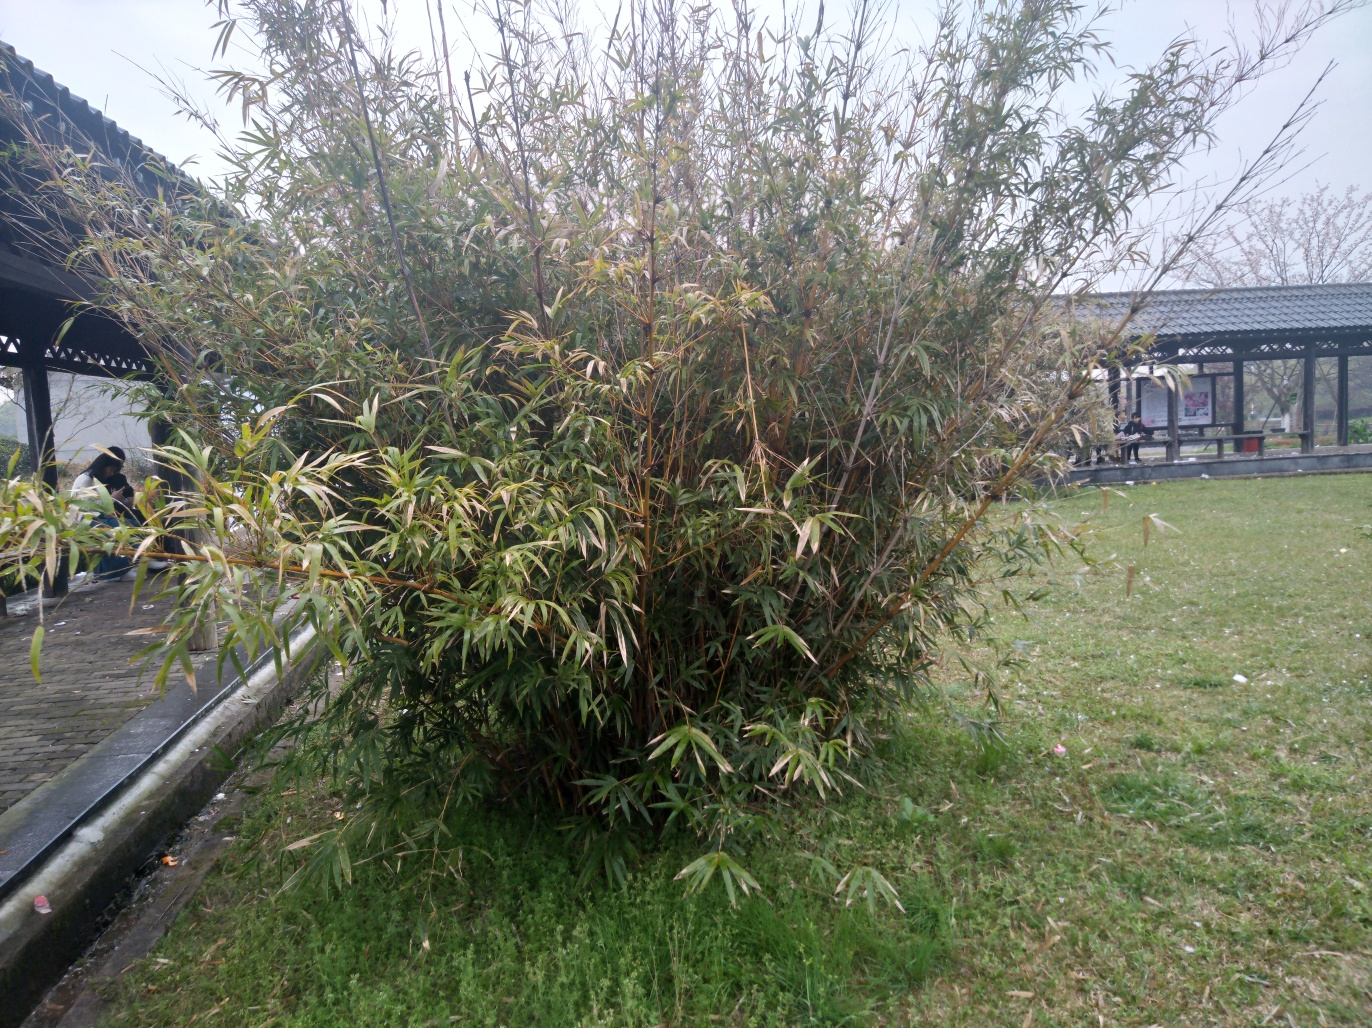What kind of place do you think this is based on the structures and setting in the image? This setting seems to be a public or communal garden, possibly part of a park. The presence of a gazebo and paved walkways suggest that it's designed for visitors to relax and enjoy the scenery. The open grass areas and neatly trimmed plants are typical of spaces maintained for leisure and outdoor activities. 